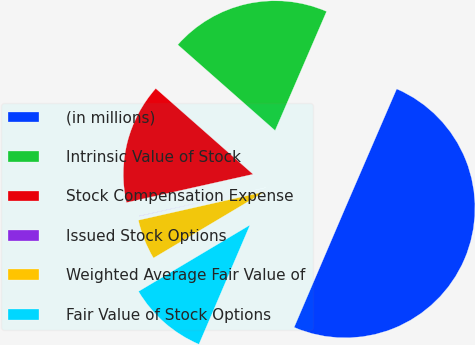Convert chart to OTSL. <chart><loc_0><loc_0><loc_500><loc_500><pie_chart><fcel>(in millions)<fcel>Intrinsic Value of Stock<fcel>Stock Compensation Expense<fcel>Issued Stock Options<fcel>Weighted Average Fair Value of<fcel>Fair Value of Stock Options<nl><fcel>49.94%<fcel>19.99%<fcel>15.0%<fcel>0.03%<fcel>5.02%<fcel>10.01%<nl></chart> 